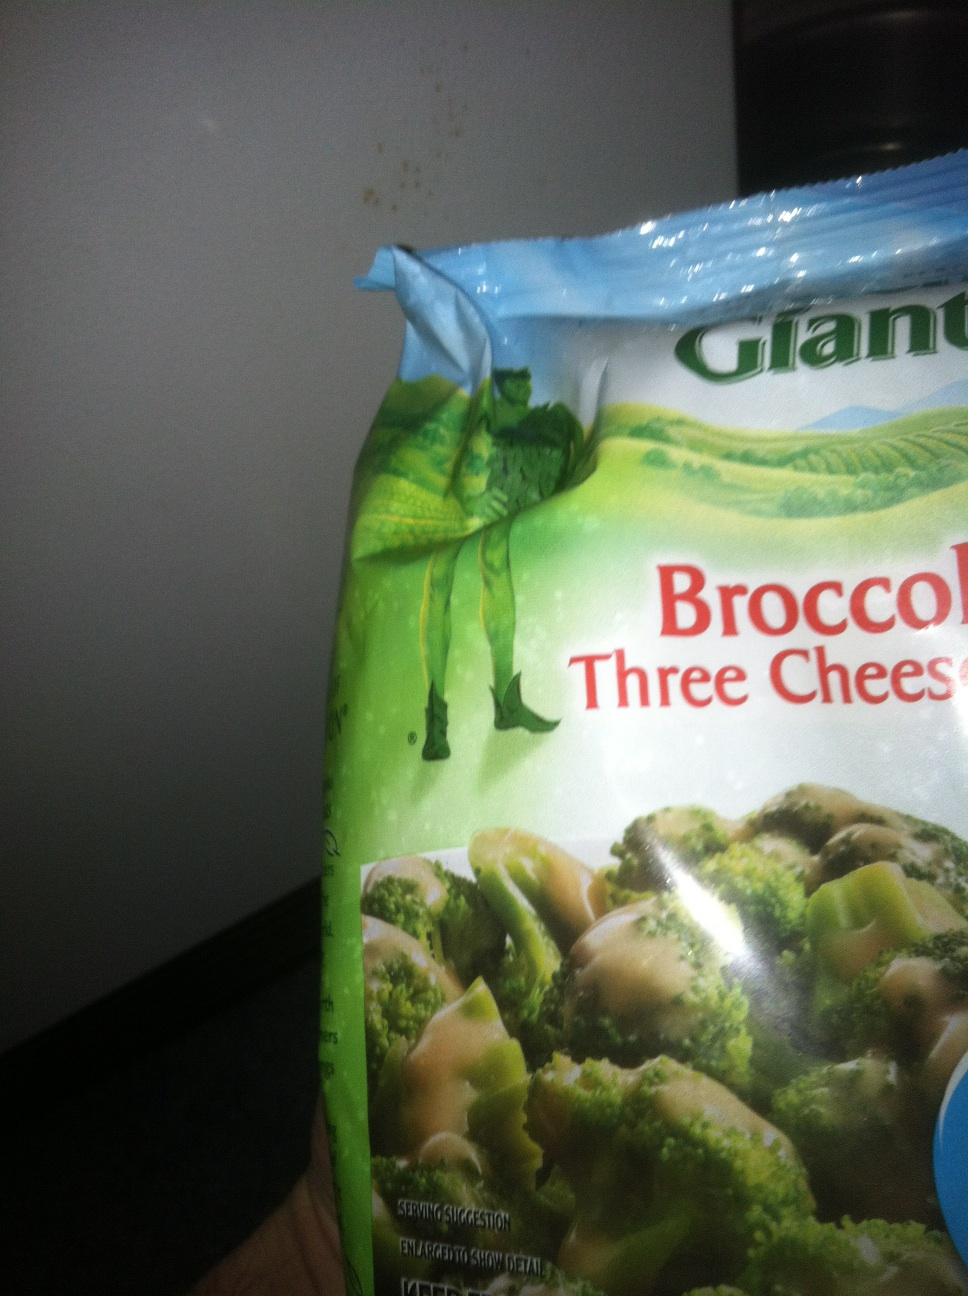What is this, please? This is a package of frozen broccoli with a three cheese sauce. The image clearly shows the product packaging of 'Green Giant Broccoli Three Cheese Sauce,' which is a popular frozen vegetable meal. 